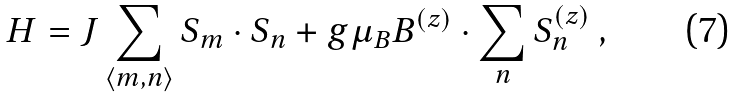Convert formula to latex. <formula><loc_0><loc_0><loc_500><loc_500>H = J \sum _ { \langle m , n \rangle } S _ { m } \cdot S _ { n } + g \mu _ { B } { B } ^ { ( z ) } \cdot \sum _ { n } { S } ^ { ( z ) } _ { n } \ ,</formula> 